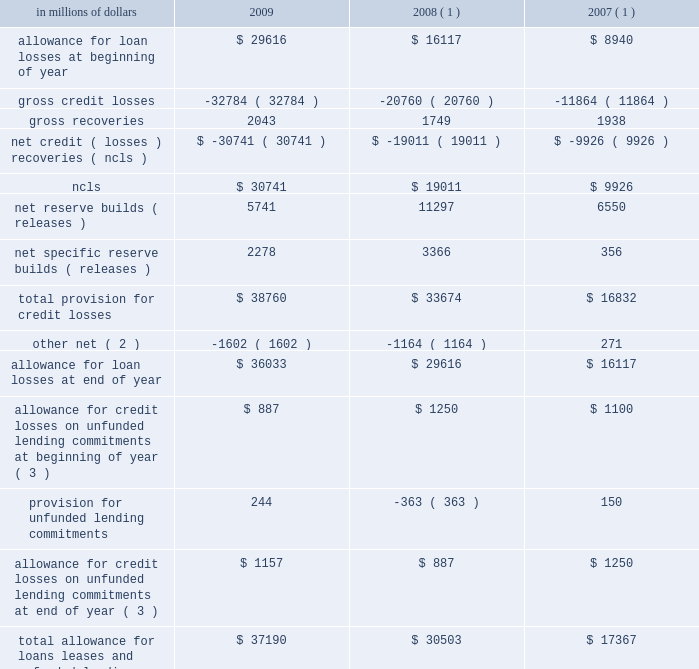18 .
Allowance for credit losses .
( 1 ) reclassified to conform to the current period 2019s presentation .
( 2 ) 2009 primarily includes reductions to the loan loss reserve of approximately $ 543 million related to securitizations , approximately $ 402 million related to the sale or transfers to held-for-sale of u.s .
Real estate lending loans , and $ 562 million related to the transfer of the u.k .
Cards portfolio to held-for-sale .
2008 primarily includes reductions to the loan loss reserve of approximately $ 800 million related to fx translation , $ 102 million related to securitizations , $ 244 million for the sale of the german retail banking operation , $ 156 million for the sale of citicapital , partially offset by additions of $ 106 million related to the cuscatl e1n and bank of overseas chinese acquisitions .
2007 primarily includes reductions to the loan loss reserve of $ 475 million related to securitizations and transfers to loans held-for-sale , and reductions of $ 83 million related to the transfer of the u.k .
Citifinancial portfolio to held-for-sale , offset by additions of $ 610 million related to the acquisitions of egg , nikko cordial , grupo cuscatl e1n and grupo financiero uno .
( 3 ) represents additional credit loss reserves for unfunded corporate lending commitments and letters of credit recorded in other liabilities on the consolidated balance sheet. .
What was the percentage change in the allowance for loan losses from 2007 to 2008? 
Computations: ((16117 - 8940) / 8940)
Answer: 0.8028. 